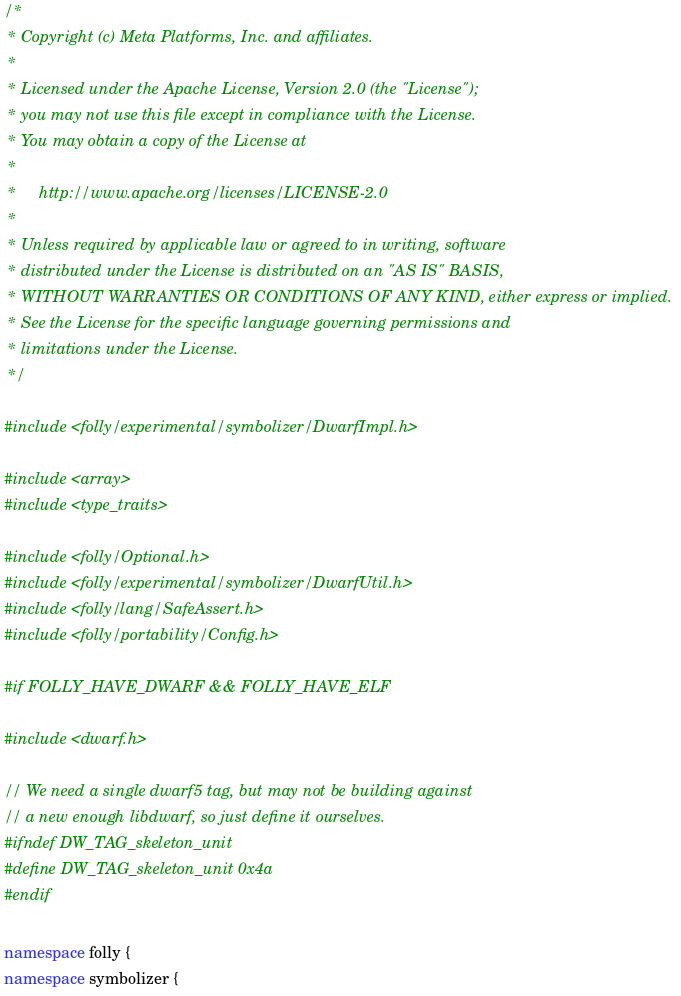Convert code to text. <code><loc_0><loc_0><loc_500><loc_500><_C++_>/*
 * Copyright (c) Meta Platforms, Inc. and affiliates.
 *
 * Licensed under the Apache License, Version 2.0 (the "License");
 * you may not use this file except in compliance with the License.
 * You may obtain a copy of the License at
 *
 *     http://www.apache.org/licenses/LICENSE-2.0
 *
 * Unless required by applicable law or agreed to in writing, software
 * distributed under the License is distributed on an "AS IS" BASIS,
 * WITHOUT WARRANTIES OR CONDITIONS OF ANY KIND, either express or implied.
 * See the License for the specific language governing permissions and
 * limitations under the License.
 */

#include <folly/experimental/symbolizer/DwarfImpl.h>

#include <array>
#include <type_traits>

#include <folly/Optional.h>
#include <folly/experimental/symbolizer/DwarfUtil.h>
#include <folly/lang/SafeAssert.h>
#include <folly/portability/Config.h>

#if FOLLY_HAVE_DWARF && FOLLY_HAVE_ELF

#include <dwarf.h>

// We need a single dwarf5 tag, but may not be building against
// a new enough libdwarf, so just define it ourselves.
#ifndef DW_TAG_skeleton_unit
#define DW_TAG_skeleton_unit 0x4a
#endif

namespace folly {
namespace symbolizer {
</code> 